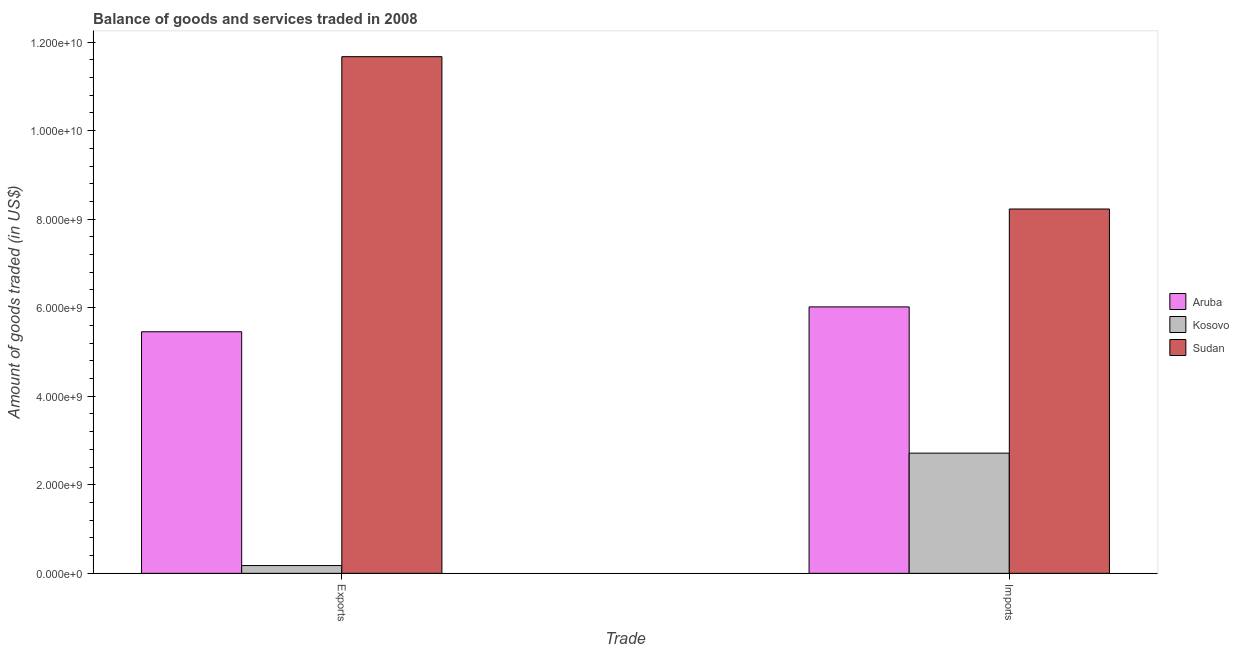How many groups of bars are there?
Keep it short and to the point. 2. Are the number of bars on each tick of the X-axis equal?
Offer a very short reply. Yes. How many bars are there on the 2nd tick from the left?
Ensure brevity in your answer.  3. What is the label of the 2nd group of bars from the left?
Your answer should be compact. Imports. What is the amount of goods imported in Kosovo?
Offer a terse response. 2.71e+09. Across all countries, what is the maximum amount of goods imported?
Your response must be concise. 8.23e+09. Across all countries, what is the minimum amount of goods imported?
Ensure brevity in your answer.  2.71e+09. In which country was the amount of goods imported maximum?
Your answer should be compact. Sudan. In which country was the amount of goods exported minimum?
Provide a succinct answer. Kosovo. What is the total amount of goods exported in the graph?
Provide a succinct answer. 1.73e+1. What is the difference between the amount of goods imported in Kosovo and that in Aruba?
Provide a short and direct response. -3.30e+09. What is the difference between the amount of goods exported in Sudan and the amount of goods imported in Aruba?
Ensure brevity in your answer.  5.65e+09. What is the average amount of goods exported per country?
Ensure brevity in your answer.  5.77e+09. What is the difference between the amount of goods imported and amount of goods exported in Sudan?
Make the answer very short. -3.44e+09. What is the ratio of the amount of goods imported in Kosovo to that in Aruba?
Your response must be concise. 0.45. In how many countries, is the amount of goods exported greater than the average amount of goods exported taken over all countries?
Give a very brief answer. 1. What does the 3rd bar from the left in Exports represents?
Your answer should be very brief. Sudan. What does the 1st bar from the right in Exports represents?
Make the answer very short. Sudan. Are all the bars in the graph horizontal?
Ensure brevity in your answer.  No. How many countries are there in the graph?
Your answer should be compact. 3. What is the difference between two consecutive major ticks on the Y-axis?
Offer a very short reply. 2.00e+09. How many legend labels are there?
Provide a short and direct response. 3. What is the title of the graph?
Your answer should be compact. Balance of goods and services traded in 2008. Does "Macao" appear as one of the legend labels in the graph?
Provide a short and direct response. No. What is the label or title of the X-axis?
Keep it short and to the point. Trade. What is the label or title of the Y-axis?
Your answer should be compact. Amount of goods traded (in US$). What is the Amount of goods traded (in US$) of Aruba in Exports?
Offer a terse response. 5.46e+09. What is the Amount of goods traded (in US$) in Kosovo in Exports?
Ensure brevity in your answer.  1.76e+08. What is the Amount of goods traded (in US$) in Sudan in Exports?
Offer a very short reply. 1.17e+1. What is the Amount of goods traded (in US$) of Aruba in Imports?
Offer a terse response. 6.02e+09. What is the Amount of goods traded (in US$) in Kosovo in Imports?
Provide a short and direct response. 2.71e+09. What is the Amount of goods traded (in US$) in Sudan in Imports?
Give a very brief answer. 8.23e+09. Across all Trade, what is the maximum Amount of goods traded (in US$) of Aruba?
Give a very brief answer. 6.02e+09. Across all Trade, what is the maximum Amount of goods traded (in US$) in Kosovo?
Ensure brevity in your answer.  2.71e+09. Across all Trade, what is the maximum Amount of goods traded (in US$) of Sudan?
Ensure brevity in your answer.  1.17e+1. Across all Trade, what is the minimum Amount of goods traded (in US$) of Aruba?
Make the answer very short. 5.46e+09. Across all Trade, what is the minimum Amount of goods traded (in US$) of Kosovo?
Keep it short and to the point. 1.76e+08. Across all Trade, what is the minimum Amount of goods traded (in US$) of Sudan?
Make the answer very short. 8.23e+09. What is the total Amount of goods traded (in US$) of Aruba in the graph?
Ensure brevity in your answer.  1.15e+1. What is the total Amount of goods traded (in US$) of Kosovo in the graph?
Your answer should be very brief. 2.89e+09. What is the total Amount of goods traded (in US$) of Sudan in the graph?
Your response must be concise. 1.99e+1. What is the difference between the Amount of goods traded (in US$) in Aruba in Exports and that in Imports?
Make the answer very short. -5.61e+08. What is the difference between the Amount of goods traded (in US$) of Kosovo in Exports and that in Imports?
Give a very brief answer. -2.54e+09. What is the difference between the Amount of goods traded (in US$) in Sudan in Exports and that in Imports?
Your response must be concise. 3.44e+09. What is the difference between the Amount of goods traded (in US$) of Aruba in Exports and the Amount of goods traded (in US$) of Kosovo in Imports?
Offer a terse response. 2.74e+09. What is the difference between the Amount of goods traded (in US$) in Aruba in Exports and the Amount of goods traded (in US$) in Sudan in Imports?
Make the answer very short. -2.77e+09. What is the difference between the Amount of goods traded (in US$) in Kosovo in Exports and the Amount of goods traded (in US$) in Sudan in Imports?
Give a very brief answer. -8.05e+09. What is the average Amount of goods traded (in US$) of Aruba per Trade?
Provide a short and direct response. 5.74e+09. What is the average Amount of goods traded (in US$) in Kosovo per Trade?
Offer a very short reply. 1.45e+09. What is the average Amount of goods traded (in US$) of Sudan per Trade?
Keep it short and to the point. 9.95e+09. What is the difference between the Amount of goods traded (in US$) in Aruba and Amount of goods traded (in US$) in Kosovo in Exports?
Your response must be concise. 5.28e+09. What is the difference between the Amount of goods traded (in US$) of Aruba and Amount of goods traded (in US$) of Sudan in Exports?
Offer a terse response. -6.21e+09. What is the difference between the Amount of goods traded (in US$) of Kosovo and Amount of goods traded (in US$) of Sudan in Exports?
Offer a terse response. -1.15e+1. What is the difference between the Amount of goods traded (in US$) of Aruba and Amount of goods traded (in US$) of Kosovo in Imports?
Ensure brevity in your answer.  3.30e+09. What is the difference between the Amount of goods traded (in US$) in Aruba and Amount of goods traded (in US$) in Sudan in Imports?
Offer a very short reply. -2.21e+09. What is the difference between the Amount of goods traded (in US$) in Kosovo and Amount of goods traded (in US$) in Sudan in Imports?
Make the answer very short. -5.51e+09. What is the ratio of the Amount of goods traded (in US$) of Aruba in Exports to that in Imports?
Your response must be concise. 0.91. What is the ratio of the Amount of goods traded (in US$) in Kosovo in Exports to that in Imports?
Your response must be concise. 0.06. What is the ratio of the Amount of goods traded (in US$) in Sudan in Exports to that in Imports?
Provide a short and direct response. 1.42. What is the difference between the highest and the second highest Amount of goods traded (in US$) of Aruba?
Ensure brevity in your answer.  5.61e+08. What is the difference between the highest and the second highest Amount of goods traded (in US$) of Kosovo?
Keep it short and to the point. 2.54e+09. What is the difference between the highest and the second highest Amount of goods traded (in US$) of Sudan?
Provide a succinct answer. 3.44e+09. What is the difference between the highest and the lowest Amount of goods traded (in US$) in Aruba?
Provide a succinct answer. 5.61e+08. What is the difference between the highest and the lowest Amount of goods traded (in US$) in Kosovo?
Give a very brief answer. 2.54e+09. What is the difference between the highest and the lowest Amount of goods traded (in US$) of Sudan?
Make the answer very short. 3.44e+09. 